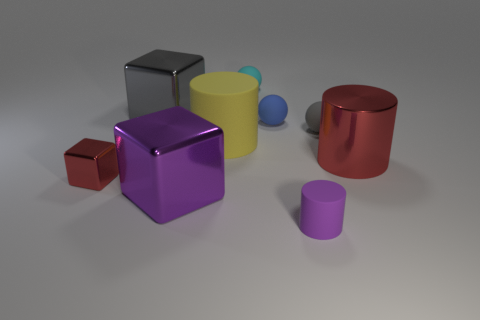Do the gray metal cube and the cyan matte sphere have the same size?
Provide a succinct answer. No. What is the size of the blue ball?
Ensure brevity in your answer.  Small. There is a small thing that is the same color as the metal cylinder; what is its shape?
Ensure brevity in your answer.  Cube. Are there more tiny objects than things?
Your answer should be compact. No. The sphere that is behind the large block that is to the left of the big purple block that is left of the small purple matte cylinder is what color?
Provide a short and direct response. Cyan. There is a tiny thing that is right of the purple matte cylinder; is its shape the same as the big yellow matte thing?
Give a very brief answer. No. What color is the rubber cylinder that is the same size as the gray rubber sphere?
Offer a very short reply. Purple. What number of shiny cubes are there?
Your response must be concise. 3. Do the large cube that is behind the large yellow cylinder and the tiny block have the same material?
Offer a very short reply. Yes. What is the object that is both right of the small cylinder and behind the large rubber cylinder made of?
Offer a very short reply. Rubber. 